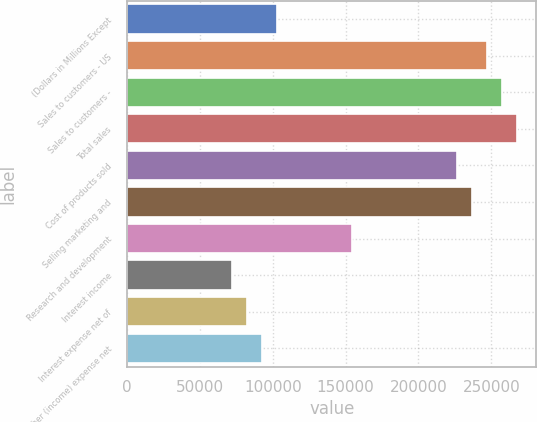Convert chart to OTSL. <chart><loc_0><loc_0><loc_500><loc_500><bar_chart><fcel>(Dollars in Millions Except<fcel>Sales to customers - US<fcel>Sales to customers -<fcel>Total sales<fcel>Cost of products sold<fcel>Selling marketing and<fcel>Research and development<fcel>Interest income<fcel>Interest expense net of<fcel>Other (income) expense net<nl><fcel>102908<fcel>246978<fcel>257269<fcel>267560<fcel>226397<fcel>236688<fcel>154362<fcel>72035.8<fcel>82326.5<fcel>92617.2<nl></chart> 